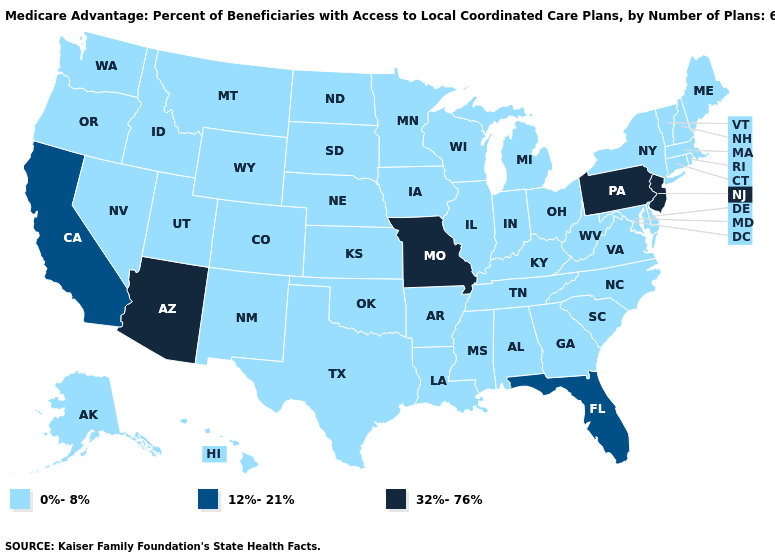Name the states that have a value in the range 12%-21%?
Keep it brief. California, Florida. Name the states that have a value in the range 12%-21%?
Answer briefly. California, Florida. Which states have the lowest value in the MidWest?
Concise answer only. Iowa, Illinois, Indiana, Kansas, Michigan, Minnesota, North Dakota, Nebraska, Ohio, South Dakota, Wisconsin. Does New Mexico have a lower value than California?
Quick response, please. Yes. Which states hav the highest value in the Northeast?
Give a very brief answer. New Jersey, Pennsylvania. Among the states that border Arkansas , which have the lowest value?
Be succinct. Louisiana, Mississippi, Oklahoma, Tennessee, Texas. Name the states that have a value in the range 0%-8%?
Be succinct. Alaska, Alabama, Arkansas, Colorado, Connecticut, Delaware, Georgia, Hawaii, Iowa, Idaho, Illinois, Indiana, Kansas, Kentucky, Louisiana, Massachusetts, Maryland, Maine, Michigan, Minnesota, Mississippi, Montana, North Carolina, North Dakota, Nebraska, New Hampshire, New Mexico, Nevada, New York, Ohio, Oklahoma, Oregon, Rhode Island, South Carolina, South Dakota, Tennessee, Texas, Utah, Virginia, Vermont, Washington, Wisconsin, West Virginia, Wyoming. Which states have the highest value in the USA?
Be succinct. Arizona, Missouri, New Jersey, Pennsylvania. Which states have the highest value in the USA?
Give a very brief answer. Arizona, Missouri, New Jersey, Pennsylvania. Which states have the lowest value in the South?
Give a very brief answer. Alabama, Arkansas, Delaware, Georgia, Kentucky, Louisiana, Maryland, Mississippi, North Carolina, Oklahoma, South Carolina, Tennessee, Texas, Virginia, West Virginia. What is the value of New Jersey?
Concise answer only. 32%-76%. Does Arizona have the highest value in the West?
Give a very brief answer. Yes. Which states have the lowest value in the MidWest?
Be succinct. Iowa, Illinois, Indiana, Kansas, Michigan, Minnesota, North Dakota, Nebraska, Ohio, South Dakota, Wisconsin. 